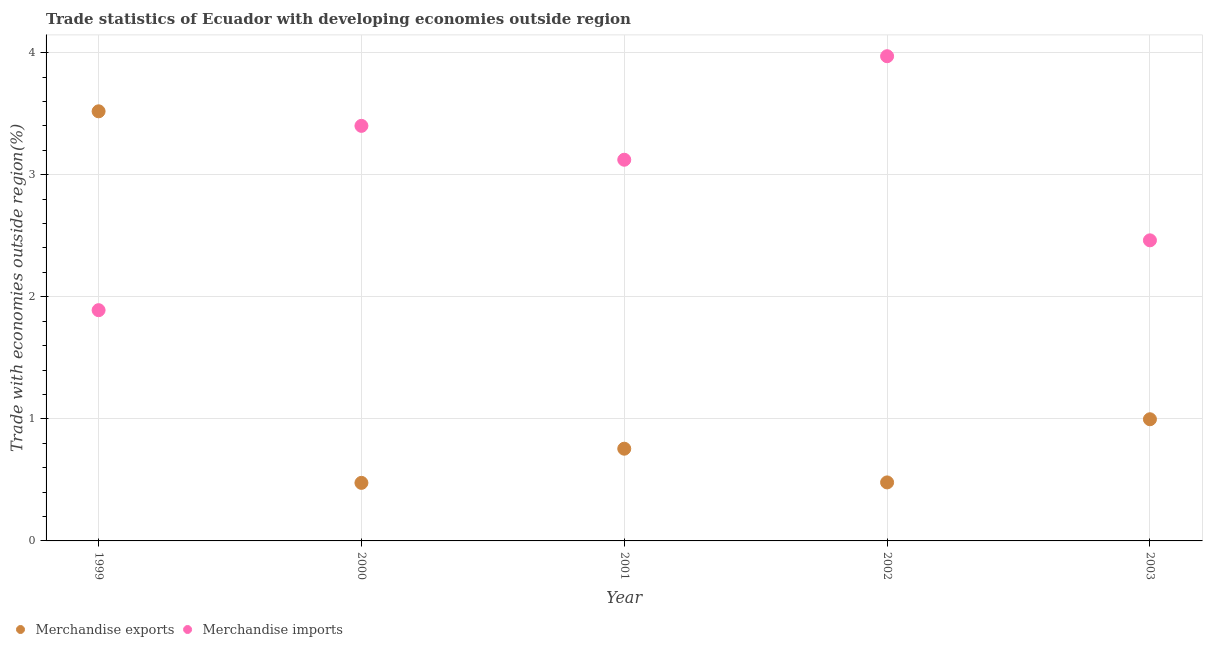How many different coloured dotlines are there?
Ensure brevity in your answer.  2. What is the merchandise exports in 2001?
Offer a very short reply. 0.76. Across all years, what is the maximum merchandise imports?
Keep it short and to the point. 3.97. Across all years, what is the minimum merchandise exports?
Provide a succinct answer. 0.48. What is the total merchandise exports in the graph?
Offer a very short reply. 6.23. What is the difference between the merchandise imports in 2000 and that in 2003?
Keep it short and to the point. 0.94. What is the difference between the merchandise exports in 1999 and the merchandise imports in 2000?
Your answer should be very brief. 0.12. What is the average merchandise exports per year?
Provide a short and direct response. 1.25. In the year 1999, what is the difference between the merchandise exports and merchandise imports?
Your response must be concise. 1.63. What is the ratio of the merchandise exports in 2002 to that in 2003?
Provide a short and direct response. 0.48. Is the difference between the merchandise exports in 1999 and 2002 greater than the difference between the merchandise imports in 1999 and 2002?
Your response must be concise. Yes. What is the difference between the highest and the second highest merchandise exports?
Provide a short and direct response. 2.52. What is the difference between the highest and the lowest merchandise imports?
Offer a very short reply. 2.08. Is the sum of the merchandise imports in 1999 and 2001 greater than the maximum merchandise exports across all years?
Give a very brief answer. Yes. Is the merchandise imports strictly greater than the merchandise exports over the years?
Your answer should be compact. No. How many years are there in the graph?
Provide a short and direct response. 5. What is the difference between two consecutive major ticks on the Y-axis?
Provide a short and direct response. 1. Are the values on the major ticks of Y-axis written in scientific E-notation?
Give a very brief answer. No. Does the graph contain any zero values?
Your answer should be very brief. No. How many legend labels are there?
Ensure brevity in your answer.  2. How are the legend labels stacked?
Your response must be concise. Horizontal. What is the title of the graph?
Give a very brief answer. Trade statistics of Ecuador with developing economies outside region. Does "Urban" appear as one of the legend labels in the graph?
Offer a terse response. No. What is the label or title of the Y-axis?
Your response must be concise. Trade with economies outside region(%). What is the Trade with economies outside region(%) of Merchandise exports in 1999?
Offer a very short reply. 3.52. What is the Trade with economies outside region(%) in Merchandise imports in 1999?
Offer a very short reply. 1.89. What is the Trade with economies outside region(%) of Merchandise exports in 2000?
Provide a short and direct response. 0.48. What is the Trade with economies outside region(%) of Merchandise imports in 2000?
Provide a succinct answer. 3.4. What is the Trade with economies outside region(%) of Merchandise exports in 2001?
Give a very brief answer. 0.76. What is the Trade with economies outside region(%) of Merchandise imports in 2001?
Give a very brief answer. 3.12. What is the Trade with economies outside region(%) of Merchandise exports in 2002?
Ensure brevity in your answer.  0.48. What is the Trade with economies outside region(%) in Merchandise imports in 2002?
Offer a very short reply. 3.97. What is the Trade with economies outside region(%) in Merchandise exports in 2003?
Offer a very short reply. 1. What is the Trade with economies outside region(%) in Merchandise imports in 2003?
Your answer should be compact. 2.46. Across all years, what is the maximum Trade with economies outside region(%) of Merchandise exports?
Ensure brevity in your answer.  3.52. Across all years, what is the maximum Trade with economies outside region(%) of Merchandise imports?
Keep it short and to the point. 3.97. Across all years, what is the minimum Trade with economies outside region(%) of Merchandise exports?
Your answer should be very brief. 0.48. Across all years, what is the minimum Trade with economies outside region(%) of Merchandise imports?
Your answer should be compact. 1.89. What is the total Trade with economies outside region(%) of Merchandise exports in the graph?
Your response must be concise. 6.23. What is the total Trade with economies outside region(%) in Merchandise imports in the graph?
Your answer should be very brief. 14.85. What is the difference between the Trade with economies outside region(%) of Merchandise exports in 1999 and that in 2000?
Your answer should be very brief. 3.04. What is the difference between the Trade with economies outside region(%) of Merchandise imports in 1999 and that in 2000?
Your answer should be very brief. -1.51. What is the difference between the Trade with economies outside region(%) of Merchandise exports in 1999 and that in 2001?
Give a very brief answer. 2.76. What is the difference between the Trade with economies outside region(%) of Merchandise imports in 1999 and that in 2001?
Make the answer very short. -1.23. What is the difference between the Trade with economies outside region(%) of Merchandise exports in 1999 and that in 2002?
Your answer should be very brief. 3.04. What is the difference between the Trade with economies outside region(%) of Merchandise imports in 1999 and that in 2002?
Provide a short and direct response. -2.08. What is the difference between the Trade with economies outside region(%) in Merchandise exports in 1999 and that in 2003?
Offer a very short reply. 2.52. What is the difference between the Trade with economies outside region(%) in Merchandise imports in 1999 and that in 2003?
Offer a very short reply. -0.57. What is the difference between the Trade with economies outside region(%) of Merchandise exports in 2000 and that in 2001?
Offer a very short reply. -0.28. What is the difference between the Trade with economies outside region(%) of Merchandise imports in 2000 and that in 2001?
Keep it short and to the point. 0.28. What is the difference between the Trade with economies outside region(%) in Merchandise exports in 2000 and that in 2002?
Make the answer very short. -0. What is the difference between the Trade with economies outside region(%) of Merchandise imports in 2000 and that in 2002?
Your response must be concise. -0.57. What is the difference between the Trade with economies outside region(%) of Merchandise exports in 2000 and that in 2003?
Your response must be concise. -0.52. What is the difference between the Trade with economies outside region(%) of Merchandise imports in 2000 and that in 2003?
Your answer should be very brief. 0.94. What is the difference between the Trade with economies outside region(%) of Merchandise exports in 2001 and that in 2002?
Your answer should be very brief. 0.28. What is the difference between the Trade with economies outside region(%) of Merchandise imports in 2001 and that in 2002?
Provide a short and direct response. -0.85. What is the difference between the Trade with economies outside region(%) in Merchandise exports in 2001 and that in 2003?
Your response must be concise. -0.24. What is the difference between the Trade with economies outside region(%) in Merchandise imports in 2001 and that in 2003?
Ensure brevity in your answer.  0.66. What is the difference between the Trade with economies outside region(%) in Merchandise exports in 2002 and that in 2003?
Make the answer very short. -0.52. What is the difference between the Trade with economies outside region(%) in Merchandise imports in 2002 and that in 2003?
Your answer should be very brief. 1.51. What is the difference between the Trade with economies outside region(%) of Merchandise exports in 1999 and the Trade with economies outside region(%) of Merchandise imports in 2000?
Offer a terse response. 0.12. What is the difference between the Trade with economies outside region(%) in Merchandise exports in 1999 and the Trade with economies outside region(%) in Merchandise imports in 2001?
Provide a succinct answer. 0.4. What is the difference between the Trade with economies outside region(%) in Merchandise exports in 1999 and the Trade with economies outside region(%) in Merchandise imports in 2002?
Provide a succinct answer. -0.45. What is the difference between the Trade with economies outside region(%) in Merchandise exports in 1999 and the Trade with economies outside region(%) in Merchandise imports in 2003?
Your response must be concise. 1.06. What is the difference between the Trade with economies outside region(%) of Merchandise exports in 2000 and the Trade with economies outside region(%) of Merchandise imports in 2001?
Give a very brief answer. -2.65. What is the difference between the Trade with economies outside region(%) in Merchandise exports in 2000 and the Trade with economies outside region(%) in Merchandise imports in 2002?
Ensure brevity in your answer.  -3.5. What is the difference between the Trade with economies outside region(%) of Merchandise exports in 2000 and the Trade with economies outside region(%) of Merchandise imports in 2003?
Provide a succinct answer. -1.99. What is the difference between the Trade with economies outside region(%) in Merchandise exports in 2001 and the Trade with economies outside region(%) in Merchandise imports in 2002?
Your answer should be very brief. -3.22. What is the difference between the Trade with economies outside region(%) of Merchandise exports in 2001 and the Trade with economies outside region(%) of Merchandise imports in 2003?
Provide a succinct answer. -1.71. What is the difference between the Trade with economies outside region(%) of Merchandise exports in 2002 and the Trade with economies outside region(%) of Merchandise imports in 2003?
Offer a terse response. -1.98. What is the average Trade with economies outside region(%) in Merchandise exports per year?
Keep it short and to the point. 1.25. What is the average Trade with economies outside region(%) in Merchandise imports per year?
Your answer should be compact. 2.97. In the year 1999, what is the difference between the Trade with economies outside region(%) of Merchandise exports and Trade with economies outside region(%) of Merchandise imports?
Offer a terse response. 1.63. In the year 2000, what is the difference between the Trade with economies outside region(%) in Merchandise exports and Trade with economies outside region(%) in Merchandise imports?
Make the answer very short. -2.92. In the year 2001, what is the difference between the Trade with economies outside region(%) of Merchandise exports and Trade with economies outside region(%) of Merchandise imports?
Provide a succinct answer. -2.37. In the year 2002, what is the difference between the Trade with economies outside region(%) of Merchandise exports and Trade with economies outside region(%) of Merchandise imports?
Ensure brevity in your answer.  -3.49. In the year 2003, what is the difference between the Trade with economies outside region(%) of Merchandise exports and Trade with economies outside region(%) of Merchandise imports?
Provide a succinct answer. -1.47. What is the ratio of the Trade with economies outside region(%) of Merchandise exports in 1999 to that in 2000?
Offer a very short reply. 7.4. What is the ratio of the Trade with economies outside region(%) of Merchandise imports in 1999 to that in 2000?
Keep it short and to the point. 0.56. What is the ratio of the Trade with economies outside region(%) in Merchandise exports in 1999 to that in 2001?
Your answer should be very brief. 4.66. What is the ratio of the Trade with economies outside region(%) in Merchandise imports in 1999 to that in 2001?
Keep it short and to the point. 0.61. What is the ratio of the Trade with economies outside region(%) in Merchandise exports in 1999 to that in 2002?
Your answer should be compact. 7.34. What is the ratio of the Trade with economies outside region(%) of Merchandise imports in 1999 to that in 2002?
Keep it short and to the point. 0.48. What is the ratio of the Trade with economies outside region(%) of Merchandise exports in 1999 to that in 2003?
Ensure brevity in your answer.  3.53. What is the ratio of the Trade with economies outside region(%) in Merchandise imports in 1999 to that in 2003?
Provide a succinct answer. 0.77. What is the ratio of the Trade with economies outside region(%) in Merchandise exports in 2000 to that in 2001?
Provide a succinct answer. 0.63. What is the ratio of the Trade with economies outside region(%) of Merchandise imports in 2000 to that in 2001?
Your answer should be very brief. 1.09. What is the ratio of the Trade with economies outside region(%) in Merchandise imports in 2000 to that in 2002?
Offer a very short reply. 0.86. What is the ratio of the Trade with economies outside region(%) of Merchandise exports in 2000 to that in 2003?
Give a very brief answer. 0.48. What is the ratio of the Trade with economies outside region(%) of Merchandise imports in 2000 to that in 2003?
Provide a short and direct response. 1.38. What is the ratio of the Trade with economies outside region(%) in Merchandise exports in 2001 to that in 2002?
Your answer should be compact. 1.58. What is the ratio of the Trade with economies outside region(%) of Merchandise imports in 2001 to that in 2002?
Make the answer very short. 0.79. What is the ratio of the Trade with economies outside region(%) of Merchandise exports in 2001 to that in 2003?
Provide a succinct answer. 0.76. What is the ratio of the Trade with economies outside region(%) of Merchandise imports in 2001 to that in 2003?
Your answer should be compact. 1.27. What is the ratio of the Trade with economies outside region(%) in Merchandise exports in 2002 to that in 2003?
Keep it short and to the point. 0.48. What is the ratio of the Trade with economies outside region(%) in Merchandise imports in 2002 to that in 2003?
Provide a short and direct response. 1.61. What is the difference between the highest and the second highest Trade with economies outside region(%) in Merchandise exports?
Your answer should be compact. 2.52. What is the difference between the highest and the second highest Trade with economies outside region(%) in Merchandise imports?
Your answer should be compact. 0.57. What is the difference between the highest and the lowest Trade with economies outside region(%) in Merchandise exports?
Offer a very short reply. 3.04. What is the difference between the highest and the lowest Trade with economies outside region(%) in Merchandise imports?
Keep it short and to the point. 2.08. 